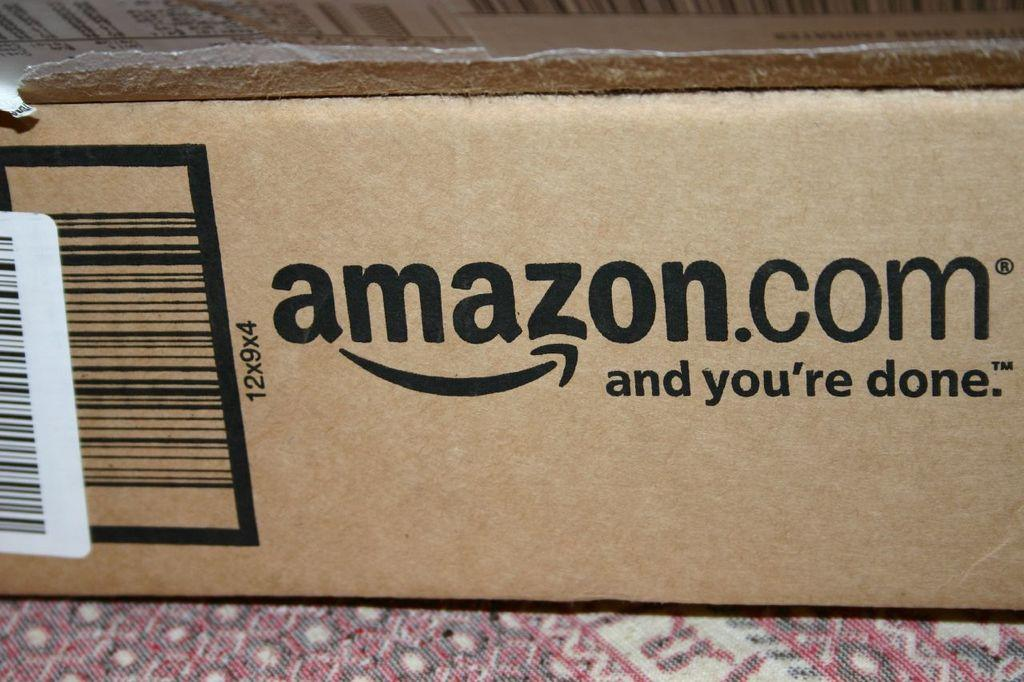<image>
Share a concise interpretation of the image provided. An Amazon.com box that says and your done on it. 